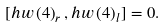<formula> <loc_0><loc_0><loc_500><loc_500>[ h w \left ( 4 \right ) _ { r } , h w \left ( 4 \right ) _ { l } ] = 0 .</formula> 